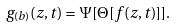<formula> <loc_0><loc_0><loc_500><loc_500>g _ { ( b ) } ( z , t ) = \Psi [ \Theta [ f ( z , t ) ] ] .</formula> 